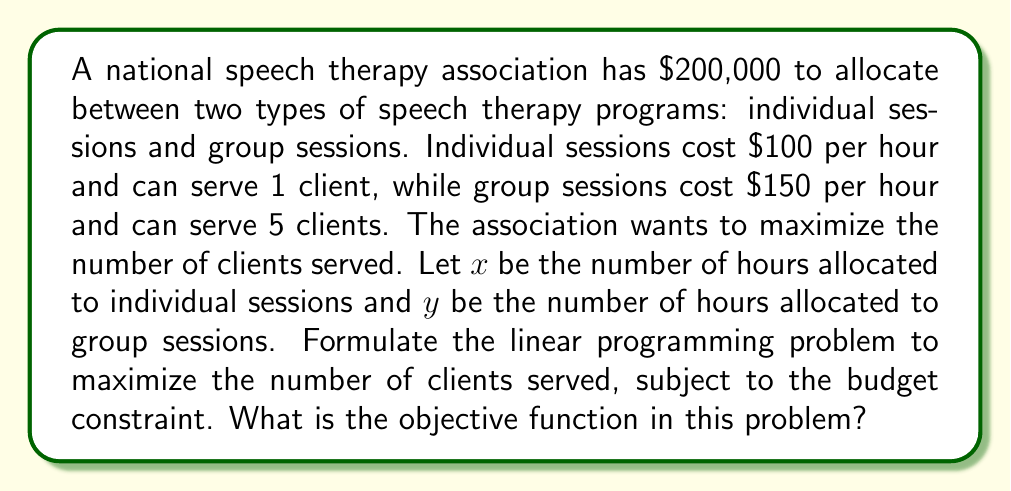Give your solution to this math problem. To formulate this linear programming problem, we need to:

1. Define the objective function
2. Identify the constraints

Step 1: Define the objective function

The goal is to maximize the number of clients served. Let's break it down:
- Individual sessions: 1 client per hour, so $x$ hours serve $x$ clients
- Group sessions: 5 clients per hour, so $y$ hours serve $5y$ clients

Total clients served = $x + 5y$

This is our objective function.

Step 2: Identify the constraints

Budget constraint:
- Cost of individual sessions: $100x$
- Cost of group sessions: $150y$
- Total budget: $200,000$

So, the budget constraint is:
$100x + 150y \leq 200,000$

Non-negativity constraints:
$x \geq 0$
$y \geq 0$

The complete linear programming problem is:

Maximize $z = x + 5y$
Subject to:
$100x + 150y \leq 200,000$
$x \geq 0$
$y \geq 0$

The objective function in this problem is $z = x + 5y$.
Answer: $z = x + 5y$ 